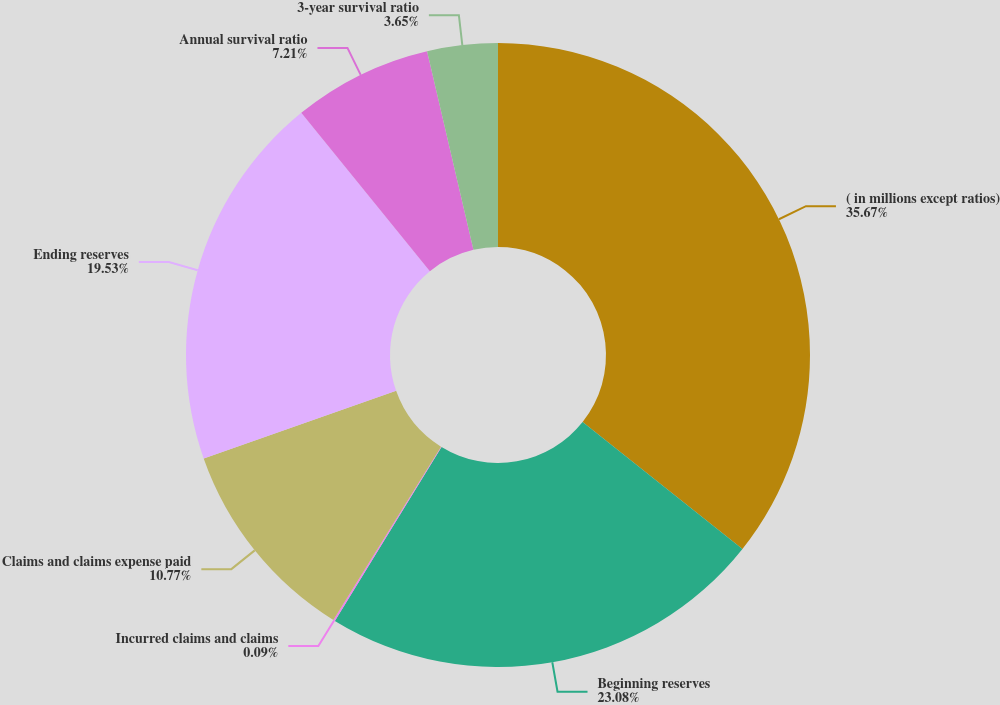<chart> <loc_0><loc_0><loc_500><loc_500><pie_chart><fcel>( in millions except ratios)<fcel>Beginning reserves<fcel>Incurred claims and claims<fcel>Claims and claims expense paid<fcel>Ending reserves<fcel>Annual survival ratio<fcel>3-year survival ratio<nl><fcel>35.68%<fcel>23.09%<fcel>0.09%<fcel>10.77%<fcel>19.53%<fcel>7.21%<fcel>3.65%<nl></chart> 